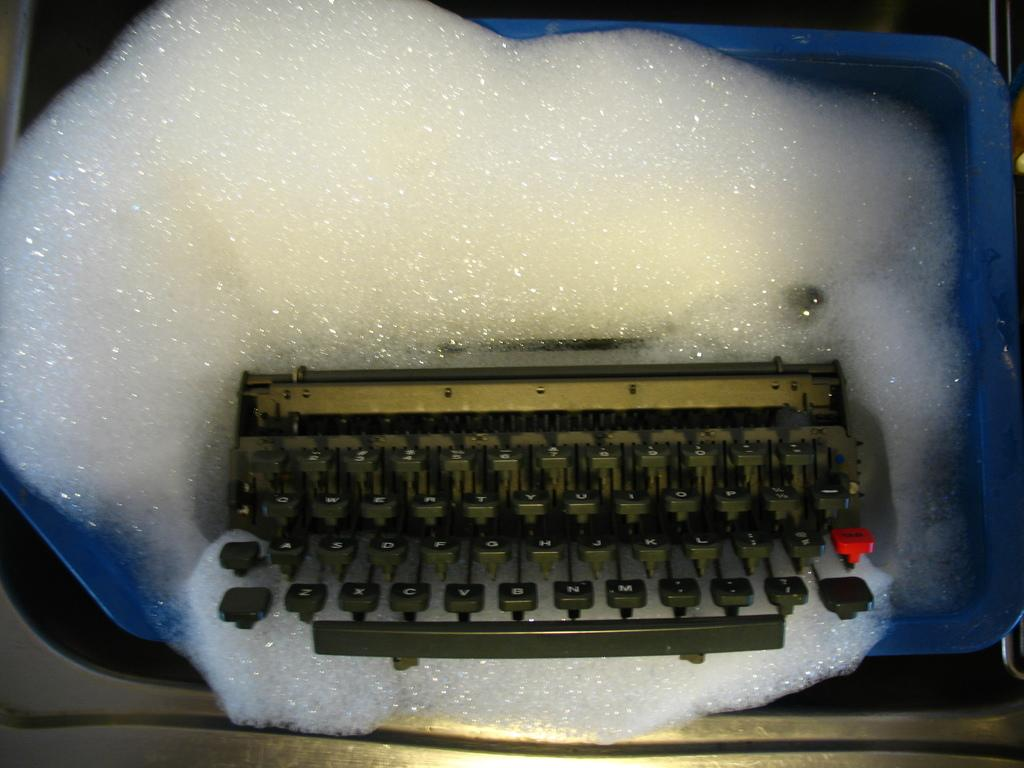<image>
Render a clear and concise summary of the photo. Vintage keyboard missing the # 1 key and sitting in soap suds. 